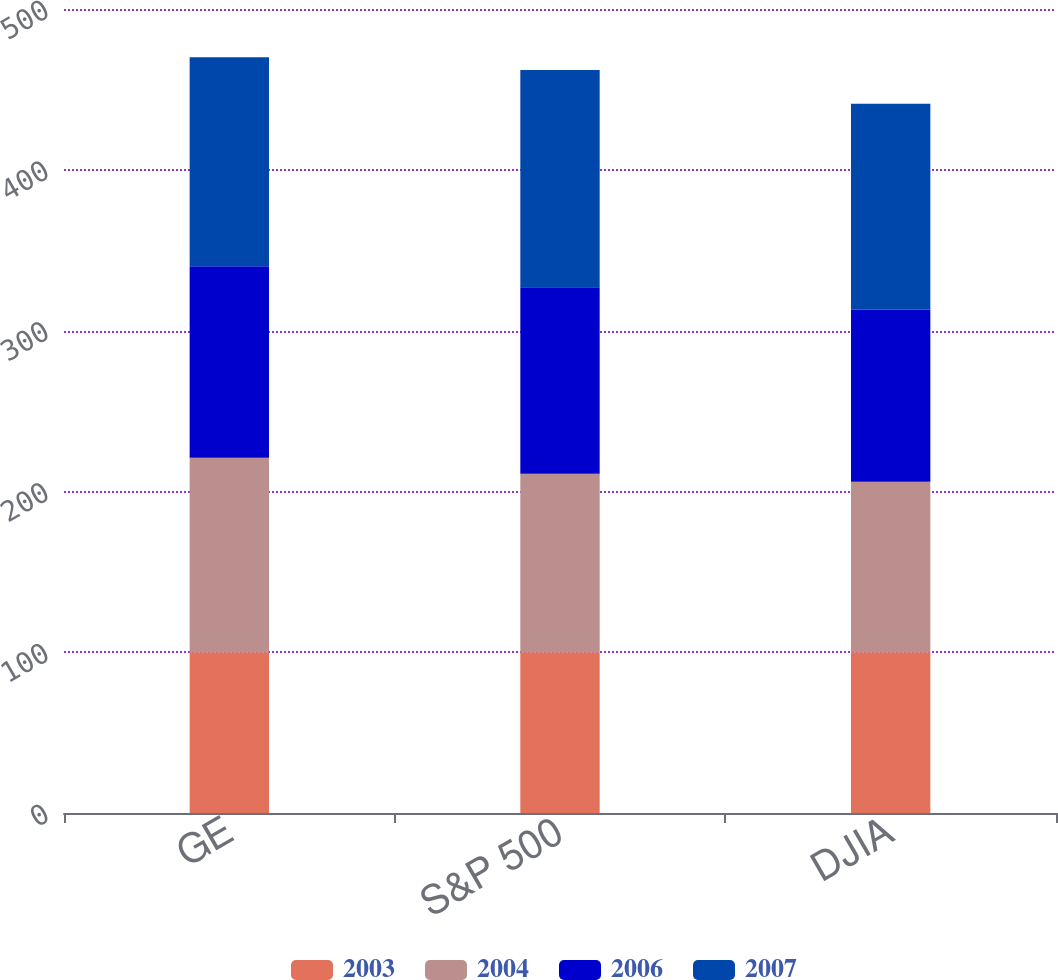Convert chart. <chart><loc_0><loc_0><loc_500><loc_500><stacked_bar_chart><ecel><fcel>GE<fcel>S&P 500<fcel>DJIA<nl><fcel>2003<fcel>100<fcel>100<fcel>100<nl><fcel>2004<fcel>121<fcel>111<fcel>106<nl><fcel>2006<fcel>119<fcel>116<fcel>107<nl><fcel>2007<fcel>130<fcel>135<fcel>128<nl></chart> 